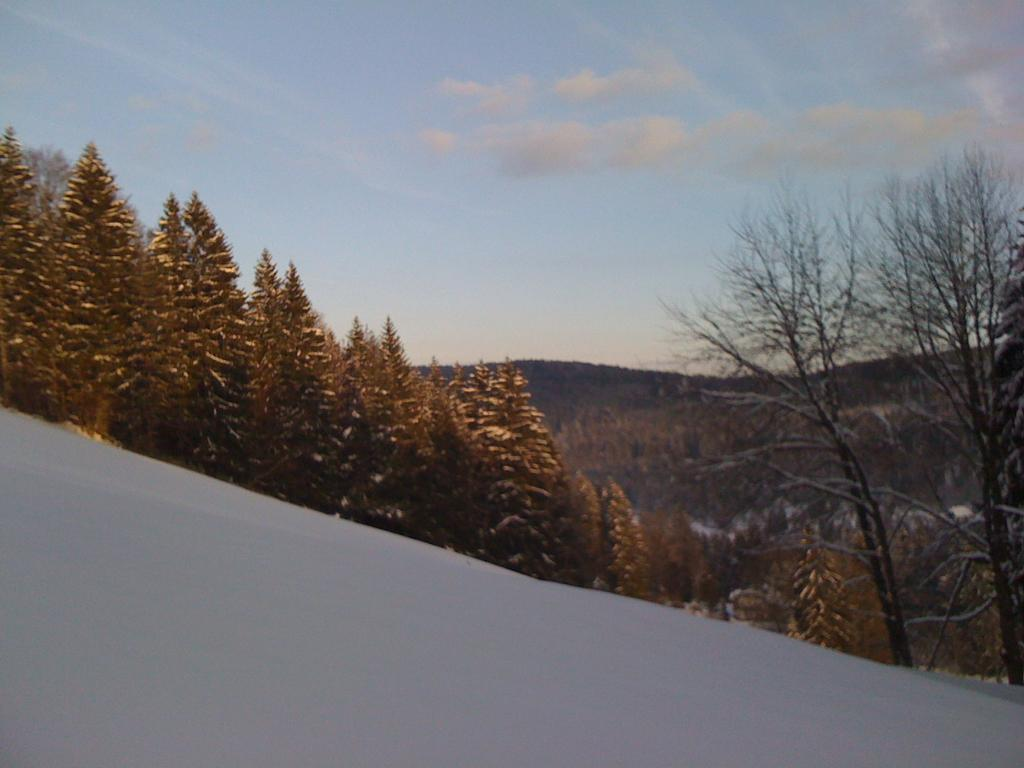Where was the image taken? The image was clicked outside. What is visible at the top of the image? There is snow and clouds in the sky at the top of the image. What can be seen in the background of the image? There are trees and mountains in the background of the image. What type of screw can be seen holding the tree branches together in the image? There is no screw visible in the image; it features snow, clouds, trees, and mountains in an outdoor setting. What season is depicted in the image, considering the presence of snow and clouds? The image does not explicitly depict a specific season, but the presence of snow suggests it could be winter. 